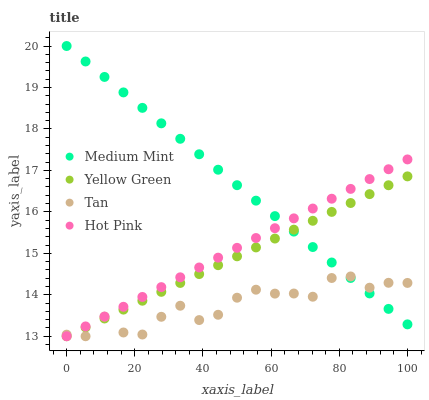Does Tan have the minimum area under the curve?
Answer yes or no. Yes. Does Medium Mint have the maximum area under the curve?
Answer yes or no. Yes. Does Hot Pink have the minimum area under the curve?
Answer yes or no. No. Does Hot Pink have the maximum area under the curve?
Answer yes or no. No. Is Hot Pink the smoothest?
Answer yes or no. Yes. Is Tan the roughest?
Answer yes or no. Yes. Is Tan the smoothest?
Answer yes or no. No. Is Hot Pink the roughest?
Answer yes or no. No. Does Tan have the lowest value?
Answer yes or no. Yes. Does Medium Mint have the highest value?
Answer yes or no. Yes. Does Hot Pink have the highest value?
Answer yes or no. No. Does Tan intersect Medium Mint?
Answer yes or no. Yes. Is Tan less than Medium Mint?
Answer yes or no. No. Is Tan greater than Medium Mint?
Answer yes or no. No. 